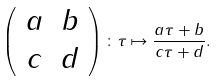Convert formula to latex. <formula><loc_0><loc_0><loc_500><loc_500>\left ( \begin{array} { c c } a & b \\ c & d \end{array} \right ) \colon \tau \mapsto \frac { a \tau + b } { c \tau + d } .</formula> 